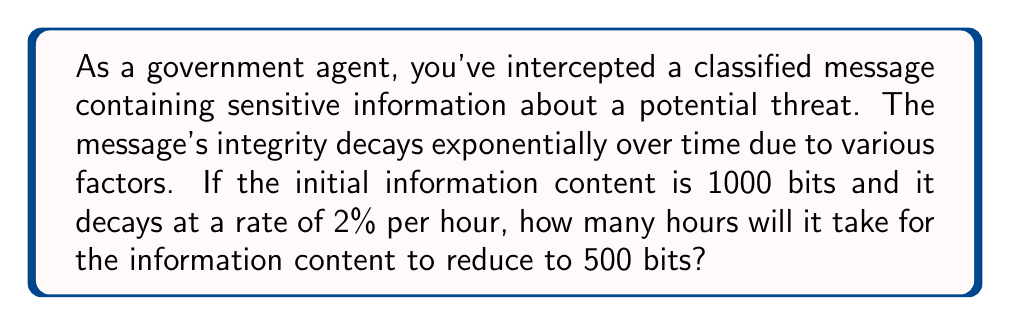Could you help me with this problem? Let's approach this step-by-step using logarithmic functions:

1) The exponential decay function is given by:
   $$A(t) = A_0 e^{-kt}$$
   where $A(t)$ is the amount at time $t$, $A_0$ is the initial amount, $k$ is the decay rate, and $t$ is time.

2) We know:
   $A_0 = 1000$ bits (initial content)
   $A(t) = 500$ bits (final content)
   $k = 0.02$ per hour (2% decay rate)

3) Substituting these values into the equation:
   $$500 = 1000 e^{-0.02t}$$

4) Dividing both sides by 1000:
   $$0.5 = e^{-0.02t}$$

5) Taking the natural logarithm of both sides:
   $$\ln(0.5) = -0.02t$$

6) Solving for $t$:
   $$t = \frac{\ln(0.5)}{-0.02}$$

7) Calculating the result:
   $$t = \frac{-0.69314718}{-0.02} \approx 34.66$$

Therefore, it will take approximately 34.66 hours for the information content to reduce to 500 bits.
Answer: 34.66 hours 